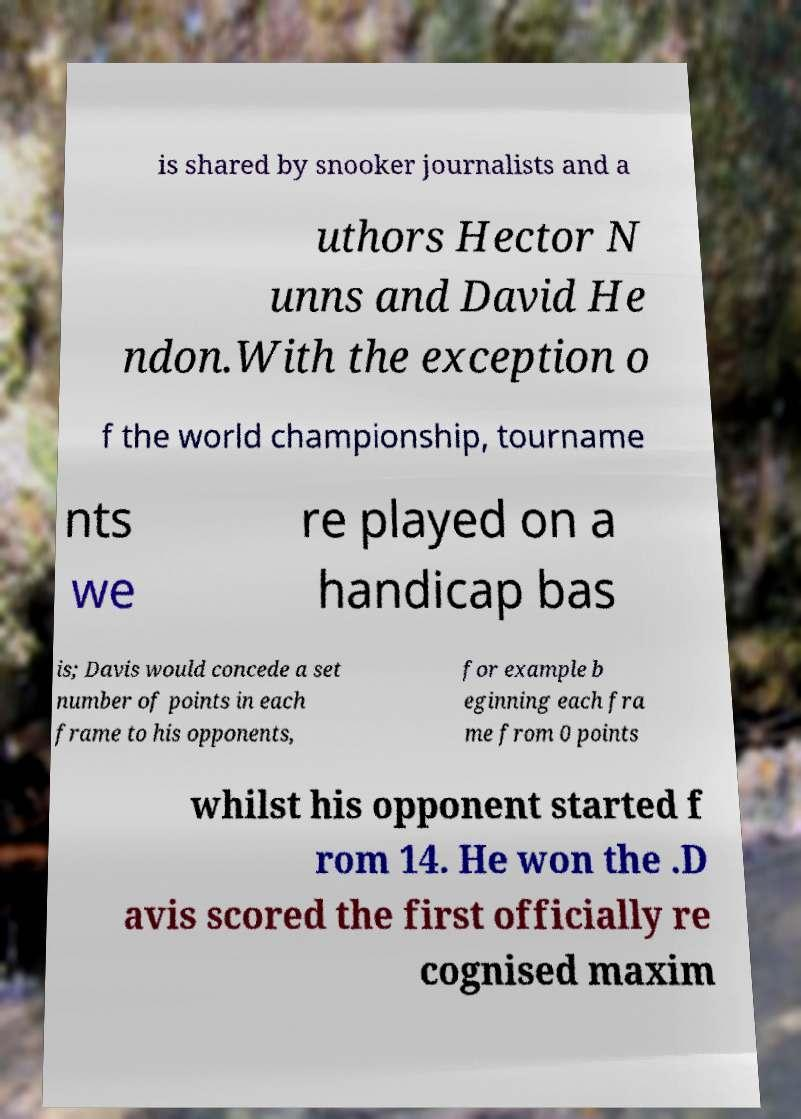Can you accurately transcribe the text from the provided image for me? is shared by snooker journalists and a uthors Hector N unns and David He ndon.With the exception o f the world championship, tourname nts we re played on a handicap bas is; Davis would concede a set number of points in each frame to his opponents, for example b eginning each fra me from 0 points whilst his opponent started f rom 14. He won the .D avis scored the first officially re cognised maxim 